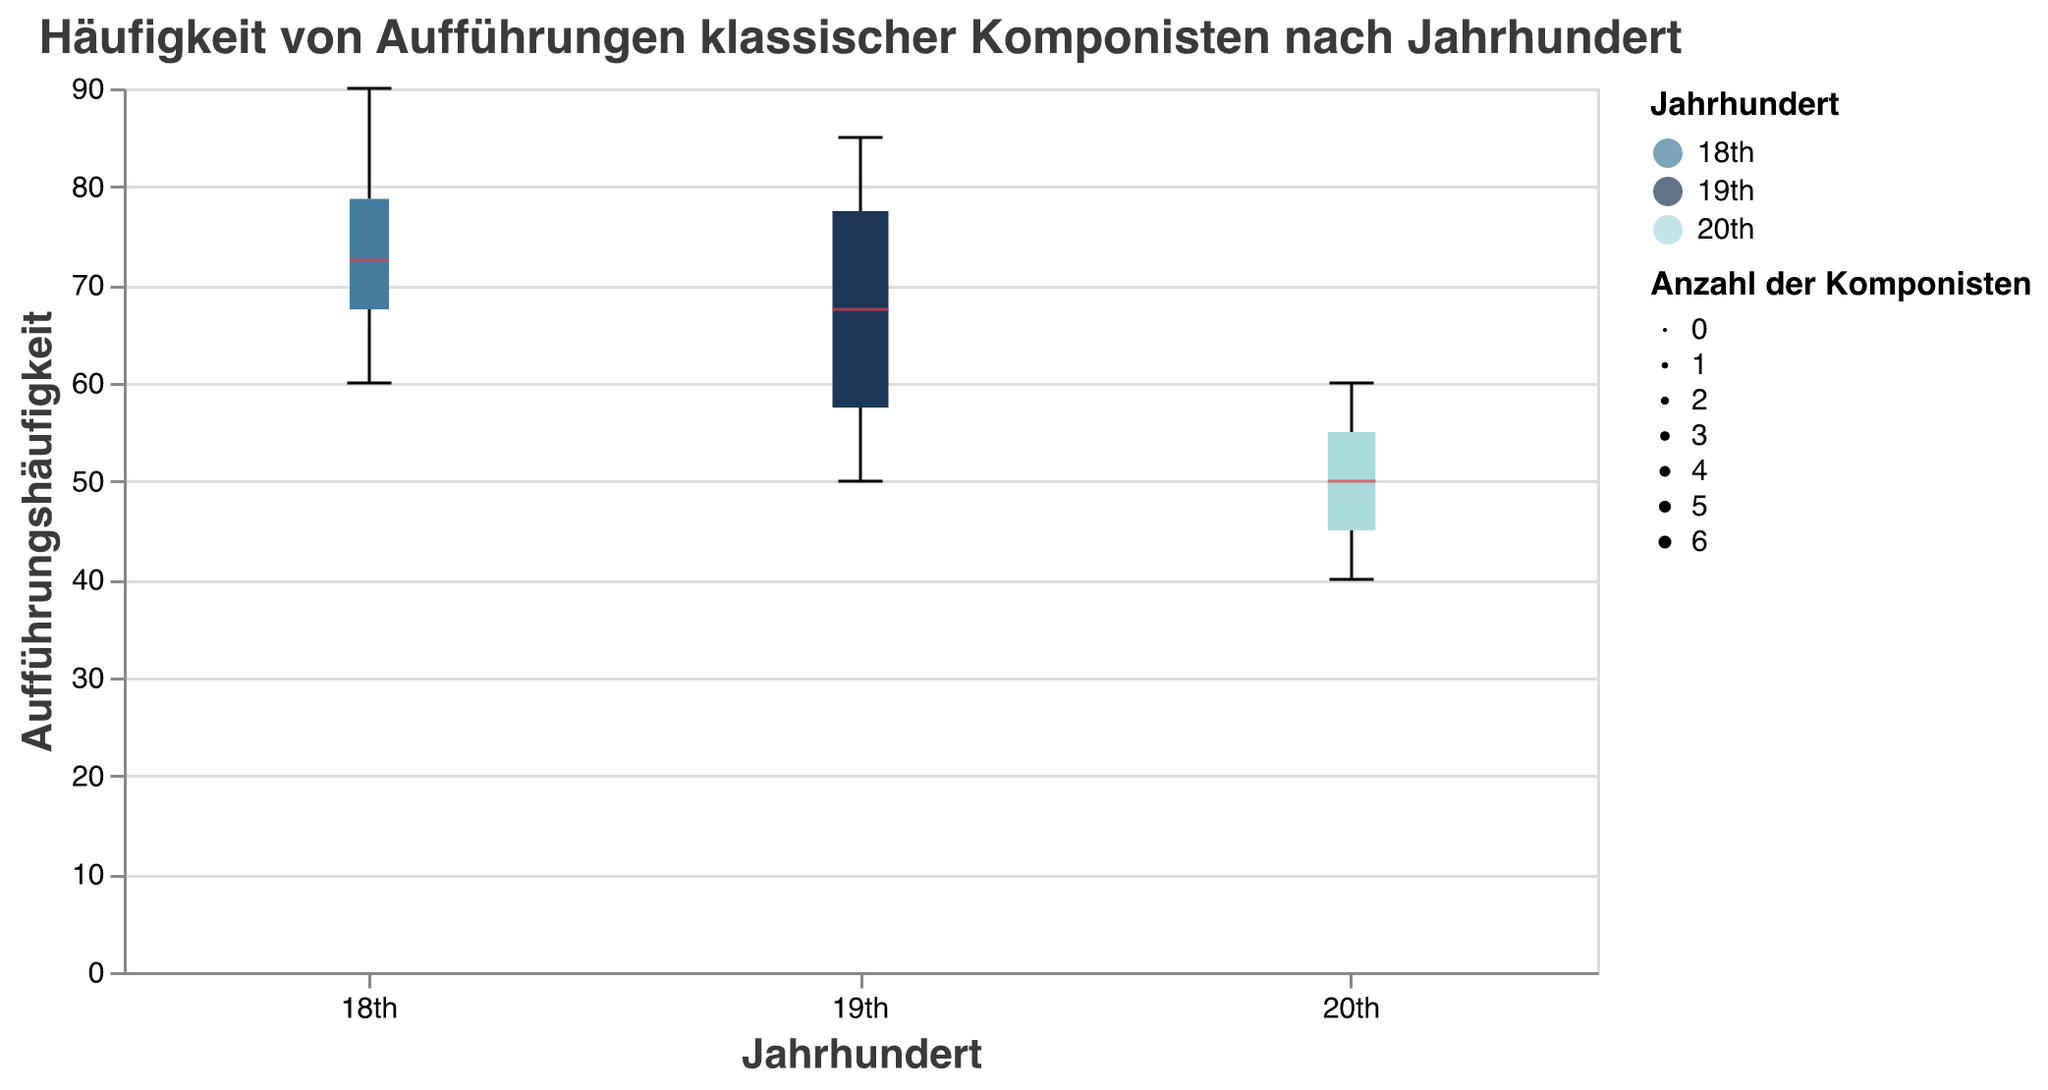How many composers are represented in the 18th century? By counting the number of composers listed under the 18th century group in the figure.
Answer: 4 What is the median performance frequency for 19th-century composers? Identifying the median line within the box plot for the 19th-century group, which is marked in red.
Answer: 65 Which century has the highest variability in performance frequency? By observing the range (difference between maximum and minimum values) of the box plots for each century, the century with the widest spread represents the highest variability.
Answer: 19th century How does the median performance frequency of the 20th century compare to that of the 18th century? Comparing the median lines within the box plots of the 18th and 20th-century groups. The median for the 20th century is lower than that of the 18th century.
Answer: Lower Which composer has the highest performance frequency, and in which century is he placed? Identifying the highest point across all the box plots and noting the composer and his century. The highest performance frequency is Wolfgang Amadeus Mozart who is placed in the 18th century.
Answer: Wolfgang Amadeus Mozart, 18th century Which century contains the majority of composers? Observing the width of the box plots which represent the number of data points (composers) in each century. The 19th century has the widest box plot.
Answer: 19th century Are there any outliers in the performance frequencies? By checking for any individual data points that fall outside the "whiskers" of the box plots.
Answer: No outliers What's the average performance frequency of 20th-century composers? Summing up the performance frequencies of the 20th-century composers (45 + 55 + 60 + 50 + 40 = 250) and then dividing by the number of composers (5).
Answer: 50 Which century has the lowest median performance frequency? By comparing the median lines of the box plots across the three centuries. The 20th century has the lowest median performance frequency.
Answer: 20th century 